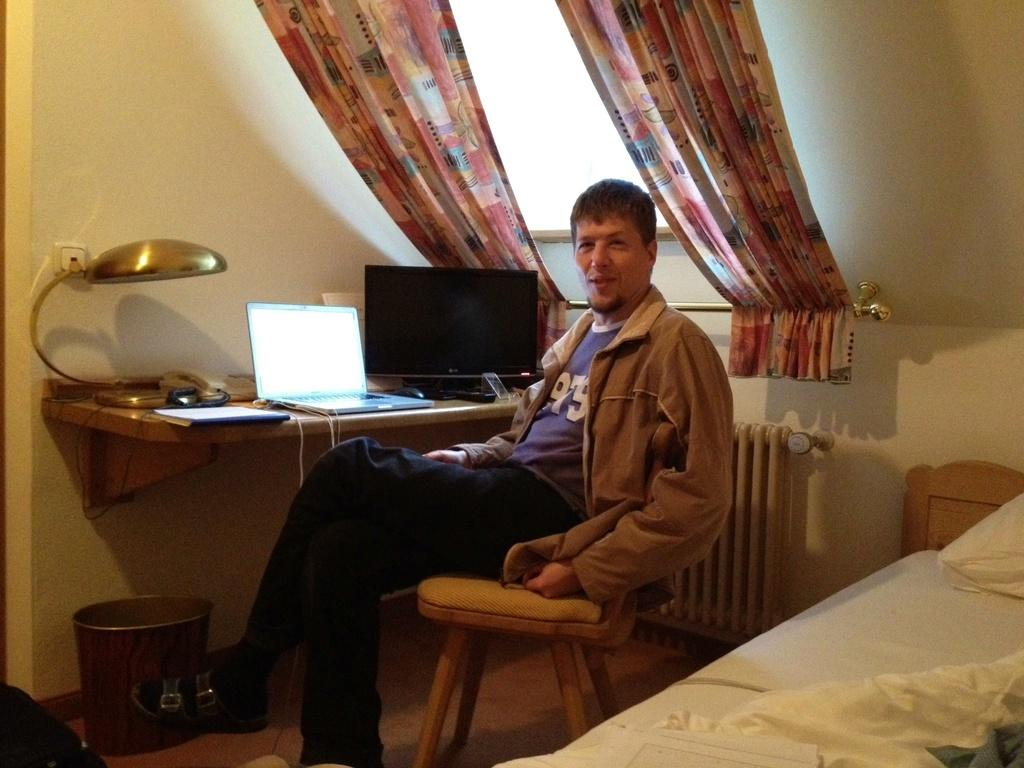What is the man in the image doing? The man is seated on a chair in the image. What electronic devices are present in the image? There is a laptop on a table and a monitor on a table in the image. What item is to the side of the man in the image? There is a bad to the side in the image. What type of zephyr can be seen blowing through the room in the image? There is no mention of a zephyr or any wind in the image; it only shows a man seated on a chair, a laptop, a monitor, and a bad. 